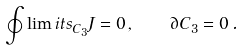Convert formula to latex. <formula><loc_0><loc_0><loc_500><loc_500>\oint \lim i t s _ { C _ { 3 } } J = 0 \, , \quad \partial C _ { 3 } = 0 \, .</formula> 